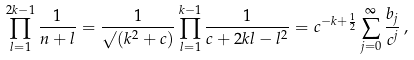Convert formula to latex. <formula><loc_0><loc_0><loc_500><loc_500>\prod _ { l = 1 } ^ { 2 k - 1 } \frac { 1 } { n + l } = \frac { 1 } { \surd ( k ^ { 2 } + c ) } \prod _ { l = 1 } ^ { k - 1 } \frac { 1 } { c + 2 k l - l ^ { 2 } } = c ^ { - k + \frac { 1 } { 2 } } \sum _ { j = 0 } ^ { \infty } \frac { b _ { j } } { c ^ { j } } \, ,</formula> 